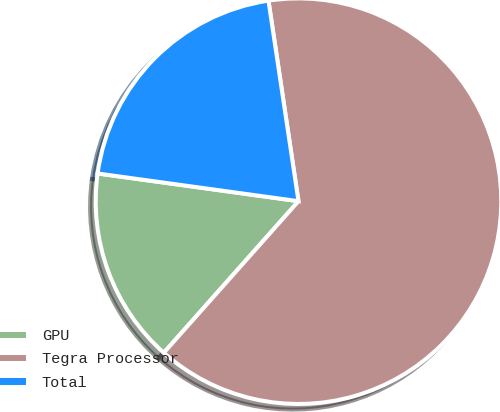Convert chart to OTSL. <chart><loc_0><loc_0><loc_500><loc_500><pie_chart><fcel>GPU<fcel>Tegra Processor<fcel>Total<nl><fcel>15.62%<fcel>63.92%<fcel>20.45%<nl></chart> 